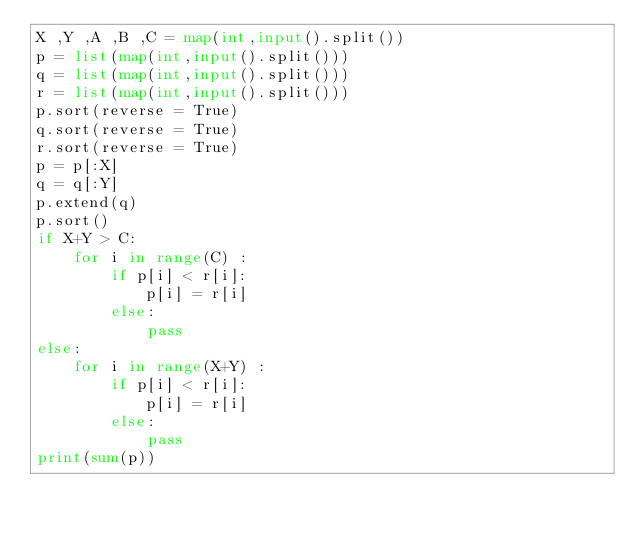Convert code to text. <code><loc_0><loc_0><loc_500><loc_500><_Python_>X ,Y ,A ,B ,C = map(int,input().split())
p = list(map(int,input().split()))
q = list(map(int,input().split()))
r = list(map(int,input().split()))
p.sort(reverse = True)
q.sort(reverse = True)
r.sort(reverse = True)
p = p[:X]
q = q[:Y]
p.extend(q)
p.sort()
if X+Y > C:
    for i in range(C) :
        if p[i] < r[i]:
            p[i] = r[i]
        else:
            pass
else:
    for i in range(X+Y) :
        if p[i] < r[i]:
            p[i] = r[i]
        else:
            pass
print(sum(p))</code> 